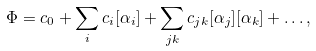<formula> <loc_0><loc_0><loc_500><loc_500>\Phi = c _ { 0 } + \sum _ { i } c _ { i } [ \alpha _ { i } ] + \sum _ { j k } c _ { j k } [ \alpha _ { j } ] [ \alpha _ { k } ] + \dots ,</formula> 